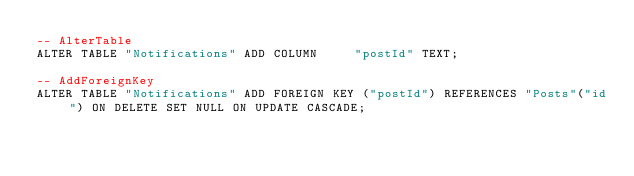<code> <loc_0><loc_0><loc_500><loc_500><_SQL_>-- AlterTable
ALTER TABLE "Notifications" ADD COLUMN     "postId" TEXT;

-- AddForeignKey
ALTER TABLE "Notifications" ADD FOREIGN KEY ("postId") REFERENCES "Posts"("id") ON DELETE SET NULL ON UPDATE CASCADE;
</code> 